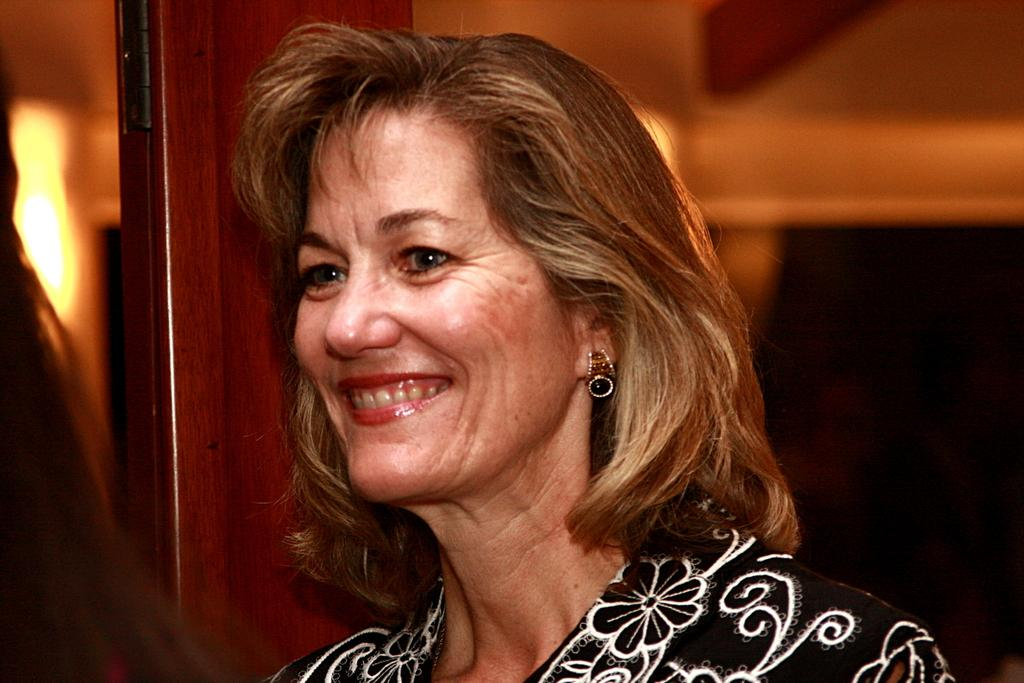Who is present in the image? There is a woman in the image. What is the woman wearing? The woman is wearing a black dress. What can be seen in the background of the image? There is a wall and light visible in the background of the image. Where is the can of paint located in the image? There is no can of paint present in the image. What type of meeting is taking place in the image? There is no meeting depicted in the image; it features a woman in a black dress with a background of a wall and light. 